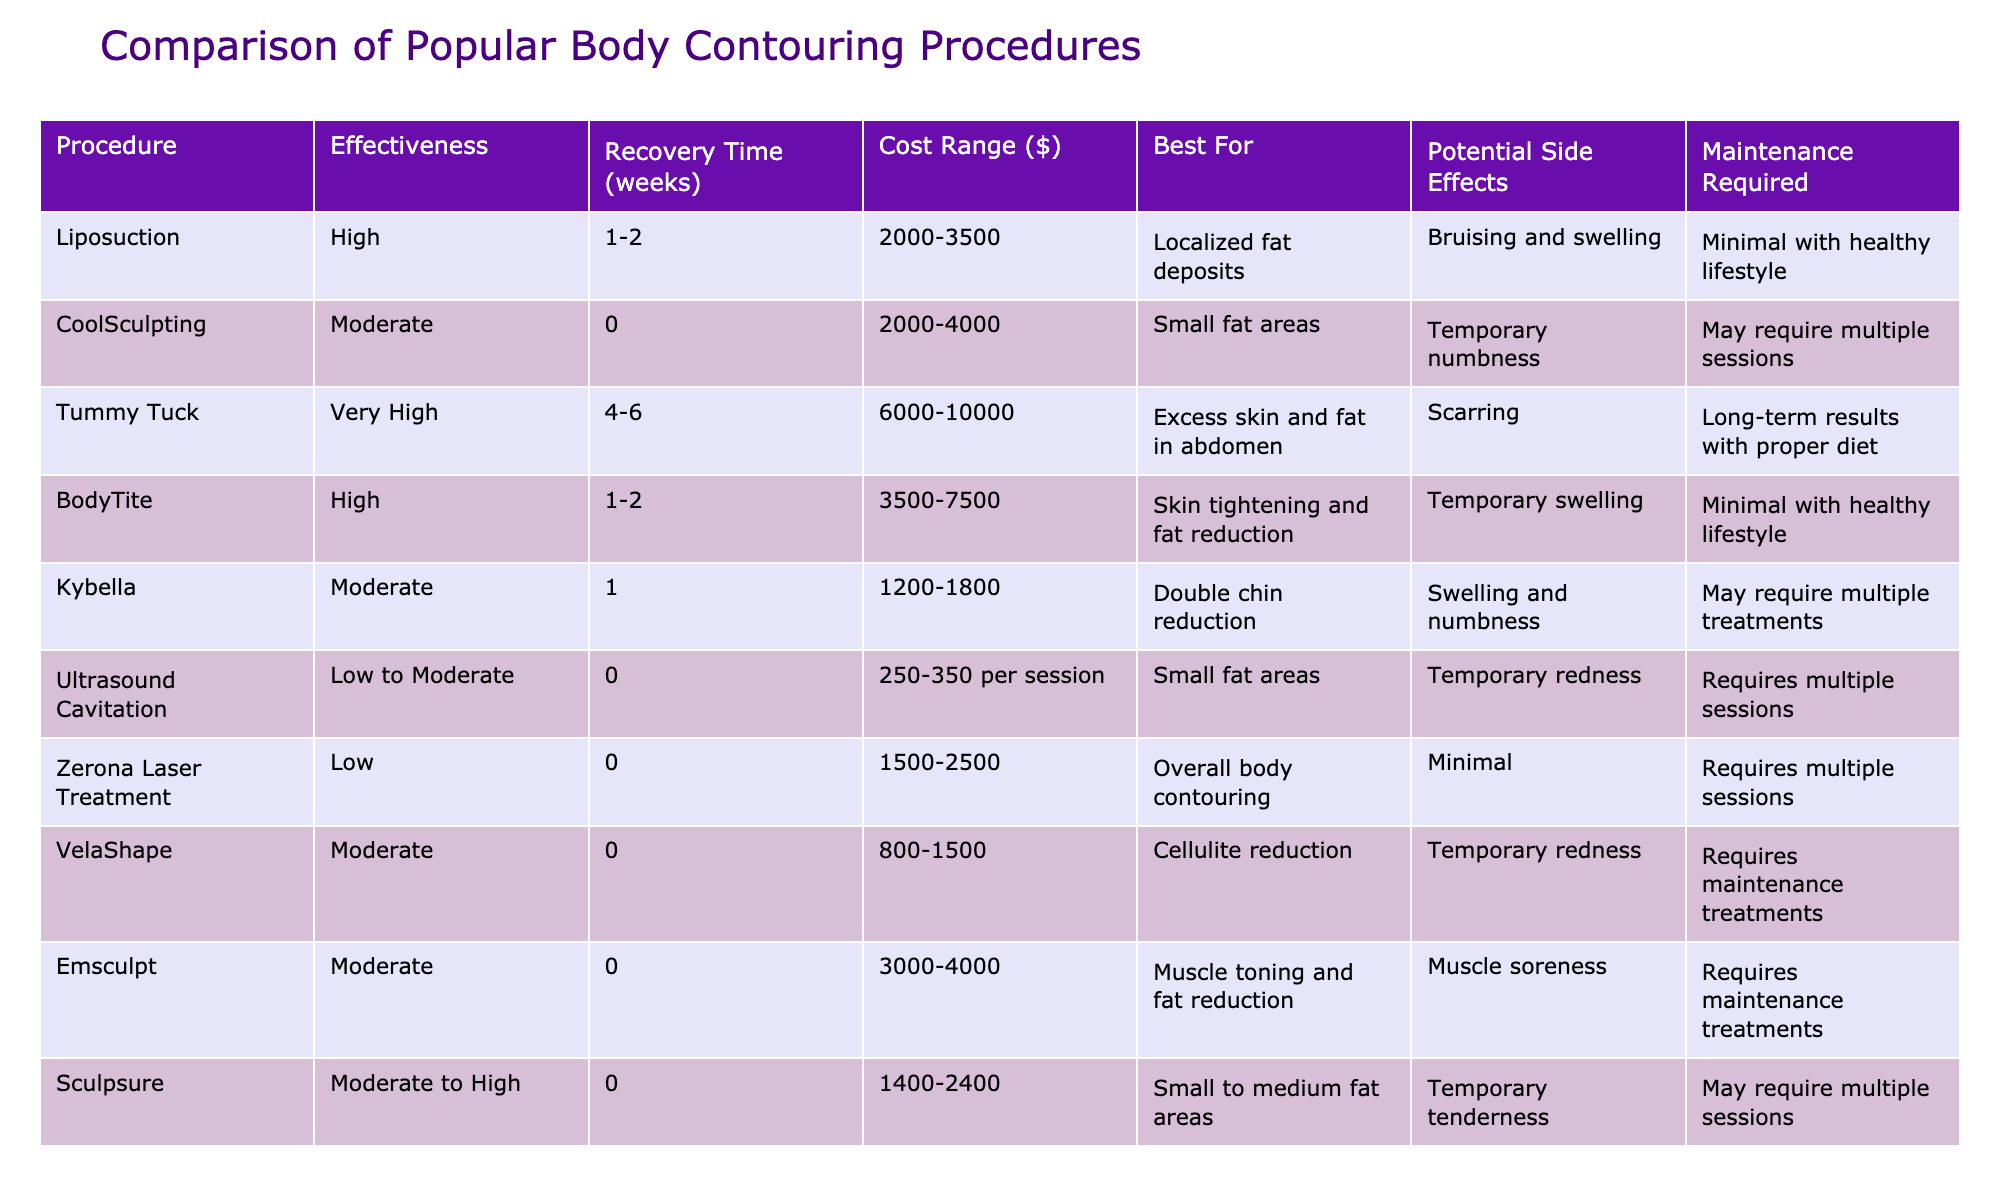What is the effectiveness rating of Liposuction? The table lists the effectiveness of each procedure, and Liposuction is described as having a "High" effectiveness rating.
Answer: High How long is the recovery time for a Tummy Tuck? The table indicates that the recovery time listed for Tummy Tuck is between 4 to 6 weeks.
Answer: 4-6 weeks Which procedure has the highest cost range? By comparing the cost ranges in the table, the Tummy Tuck has the highest range from $6000 to $10000.
Answer: Tummy Tuck Is CoolSculpting suitable for larger fat areas? The table specifically states that CoolSculpting is best for small fat areas, indicating it is not suitable for larger fat areas.
Answer: No What is the maintenance requirement for Kybella? The table informs that Kybella may require multiple treatments for maintenance.
Answer: Yes Compare the effectiveness of BodyTite and Emsculpt. Which one is more effective? BodyTite has a "High" effectiveness rating, while Emsculpt has a "Moderate" effectiveness rating, indicating BodyTite is more effective than Emsculpt.
Answer: BodyTite is more effective What is the total cost range for all procedures listed? Summing up the minimum and maximum cost ranges provided in the table would require checking their ranges. The most extensive costs are for Tummy Tuck ($6000-$10000) and Liposuction ($2000-$3500), providing a substantial range; however, for a total, you just reference the highest and lowest cost from the list. The lowest being $250-$350 per session (Ultrasound Cavitation), while the highest is Tummy Tuck at $6000-$10000.
Answer: $250 to $10000 For which procedure is temporary redness a potential side effect? The table shows that both Ultrasound Cavitation and VelaShape mention temporary redness as a potential side effect.
Answer: Ultrasound Cavitation and VelaShape How does the recovery time for Sculpsure compare to that of Liposuction? The recovery time for Sculpsure is noted as 0 weeks, compared to Liposuction's 1-2 weeks, thus Sculpsure has no recovery time while Liposuction does.
Answer: Sculpsure has no recovery time; Liposuction has 1-2 weeks Which procedure has the shortest recovery time? Looking at the recovery times listed, CoolSculpting, Ultrasound Cavitation, and Sculpsure all have a recovery time of 0 weeks, making them the shortest.
Answer: CoolSculpting, Ultrasound Cavitation, and Sculpsure If a person wants to reduce a double chin, which procedure is recommended? The table indicates that Kybella is specifically for double chin reduction; therefore, it is the recommended choice.
Answer: Kybella 